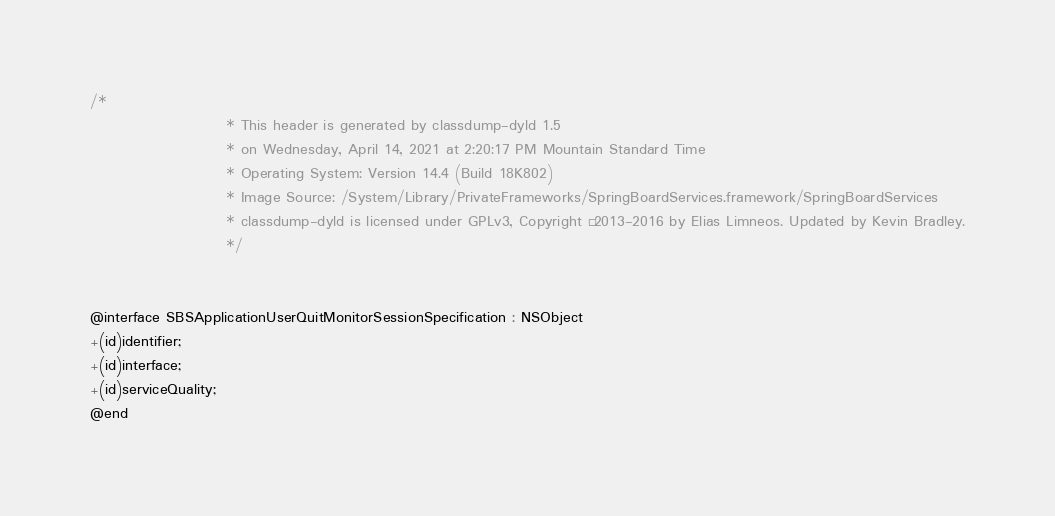<code> <loc_0><loc_0><loc_500><loc_500><_C_>/*
                       * This header is generated by classdump-dyld 1.5
                       * on Wednesday, April 14, 2021 at 2:20:17 PM Mountain Standard Time
                       * Operating System: Version 14.4 (Build 18K802)
                       * Image Source: /System/Library/PrivateFrameworks/SpringBoardServices.framework/SpringBoardServices
                       * classdump-dyld is licensed under GPLv3, Copyright © 2013-2016 by Elias Limneos. Updated by Kevin Bradley.
                       */


@interface SBSApplicationUserQuitMonitorSessionSpecification : NSObject
+(id)identifier;
+(id)interface;
+(id)serviceQuality;
@end

</code> 